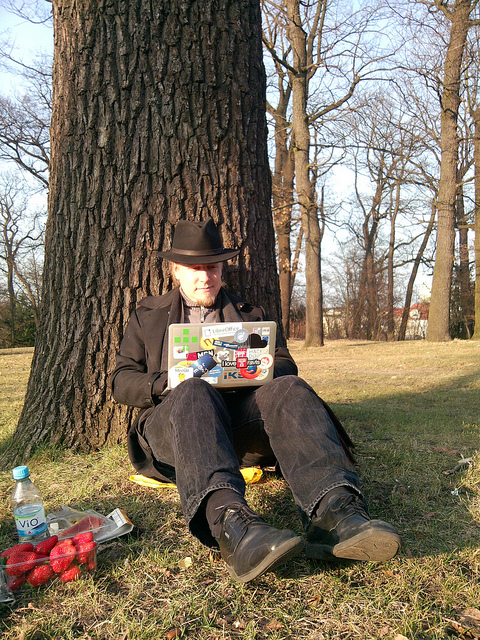Please identify all text content in this image. ViO 